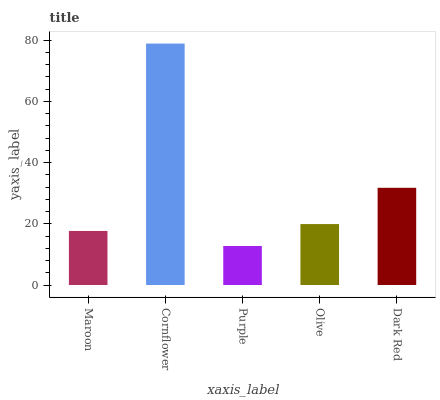Is Cornflower the maximum?
Answer yes or no. Yes. Is Cornflower the minimum?
Answer yes or no. No. Is Purple the maximum?
Answer yes or no. No. Is Cornflower greater than Purple?
Answer yes or no. Yes. Is Purple less than Cornflower?
Answer yes or no. Yes. Is Purple greater than Cornflower?
Answer yes or no. No. Is Cornflower less than Purple?
Answer yes or no. No. Is Olive the high median?
Answer yes or no. Yes. Is Olive the low median?
Answer yes or no. Yes. Is Dark Red the high median?
Answer yes or no. No. Is Maroon the low median?
Answer yes or no. No. 